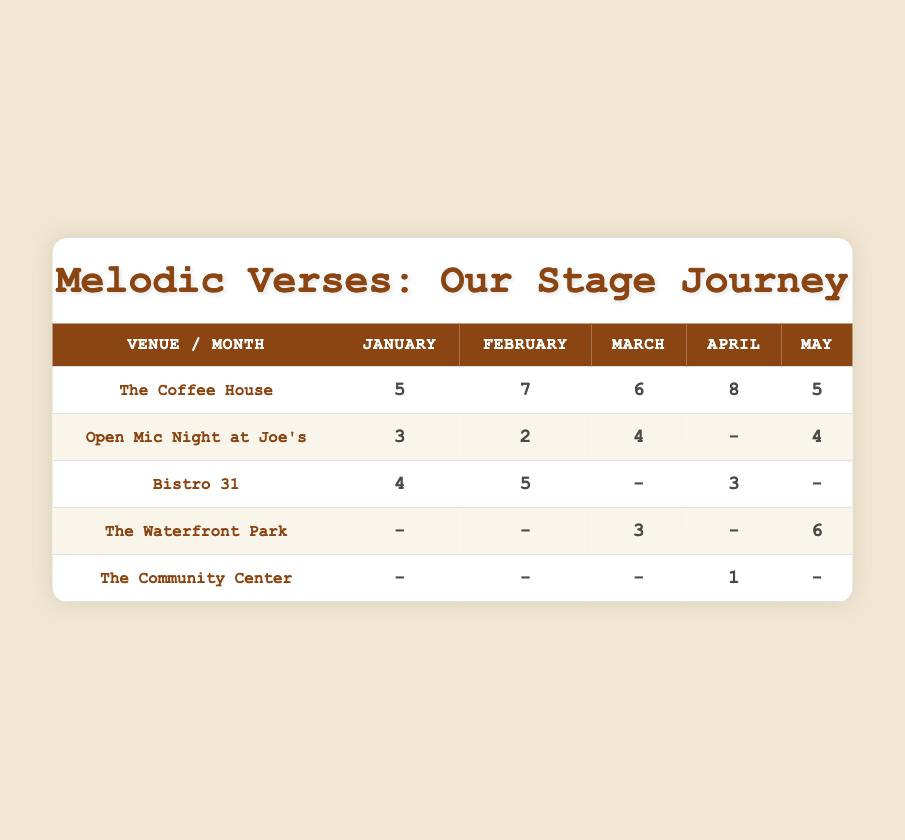What is the total number of performances at The Coffee House in April? According to the table, The Coffee House had 8 performances in April.
Answer: 8 Which month had the highest performance count at Bistro 31? Looking at the Bistro 31 row, February has the highest performance count with 5 performances.
Answer: February True or False: The Community Center had performances in every month from January to May. The table shows that The Community Center only had a performance in April (1 performance), and no performances in the other months, making this statement false.
Answer: False What is the total number of performances held by the amateur band at Open Mic Night at Joe's across all months? The performances are: January (3), February (2), March (4), and May (4). Adding these gives 3 + 2 + 4 + 4 = 13 performances.
Answer: 13 Which venue had the highest total number of performances during the five months combined? The total performances are: The Coffee House (5 + 7 + 6 + 8 + 5 = 31), Open Mic Night at Joe's (3 + 2 + 4 + 0 + 4 = 13), Bistro 31 (4 + 5 + 0 + 3 + 0 = 12), The Waterfront Park (0 + 0 + 3 + 0 + 6 = 9), The Community Center (0 + 0 + 0 + 1 + 0 = 1). The Coffee House has the highest at 31.
Answer: The Coffee House What was the total number of performances in March across all venues? Summing the performances in March: The Coffee House (6), The Waterfront Park (3), Open Mic Night at Joe's (4), and Bistro 31 (0). Therefore, the total is 6 + 3 + 4 + 0 + 0 = 13 performances.
Answer: 13 